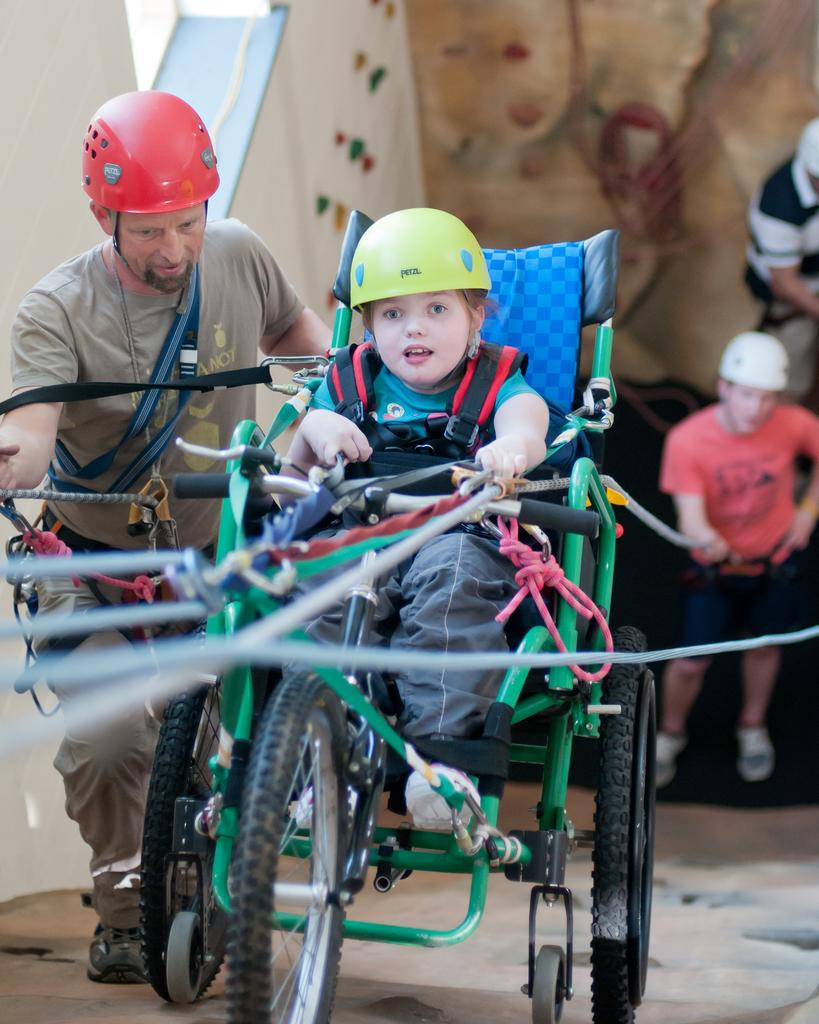What is the child doing in the image? The child is sitting in a vehicle. What are the people in the image doing? There are people standing in the image. What are the two men holding? The two men are holding ropes. What can be seen in the background of the image? There is a wall visible in the image. What type of beam is the child using to bite in the image? There is no beam or biting action present in the image. 